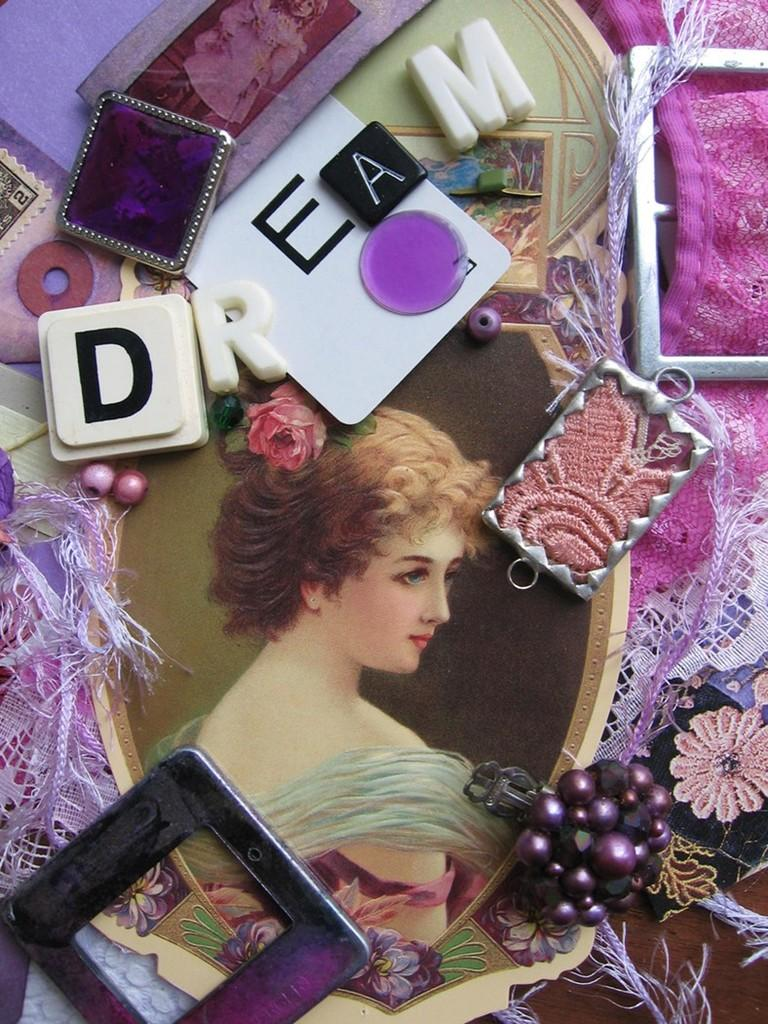What can be seen in the image that has a defined structure? There is a frame in the image. What is written or depicted within the frame? There are letters in the image. What type of tin can be seen in the image? There is no tin present in the image. What seeds are visible in the image? There are no seeds visible in the image. 